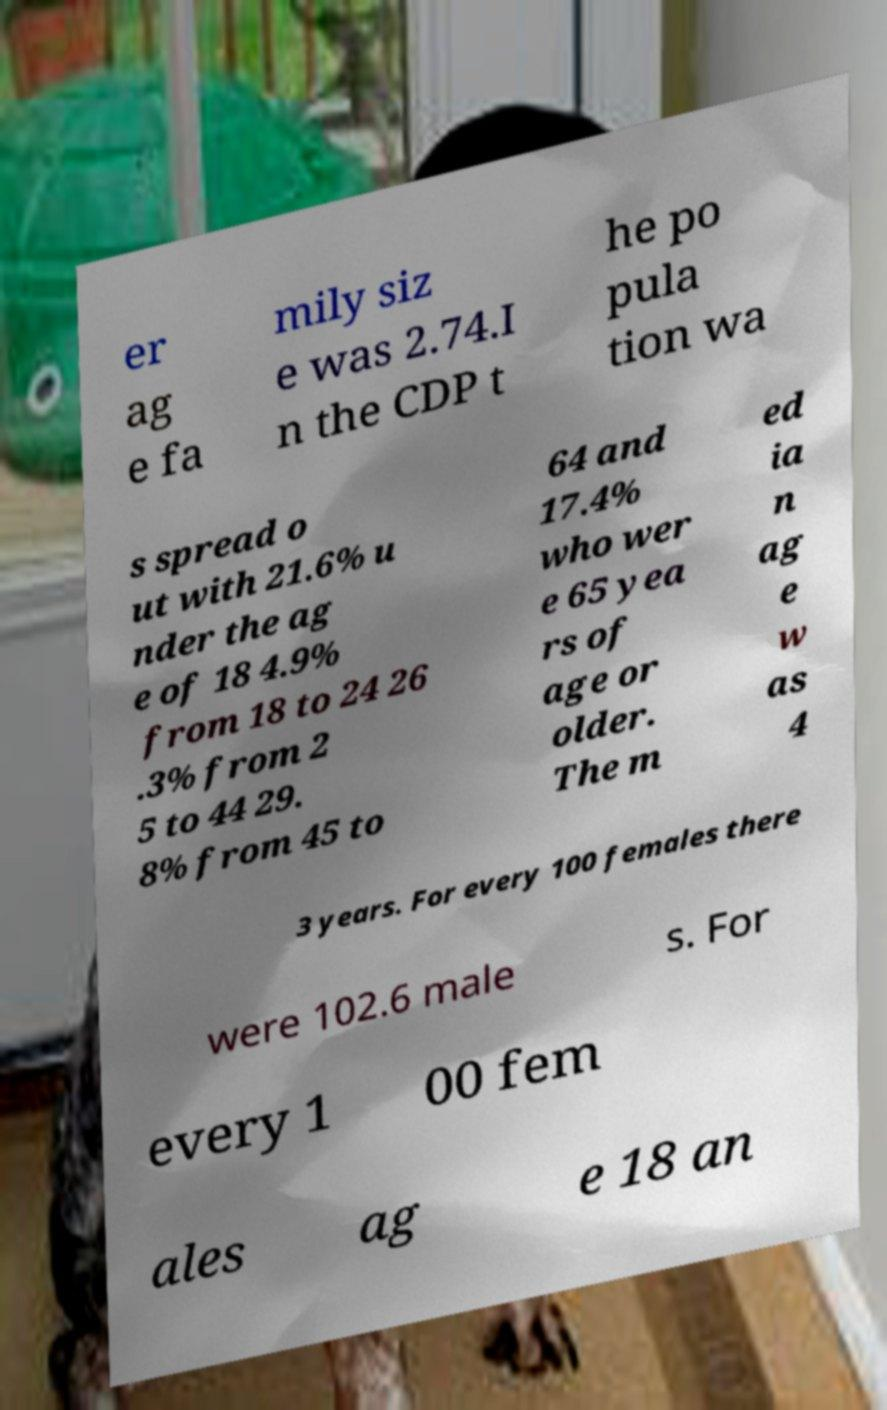For documentation purposes, I need the text within this image transcribed. Could you provide that? er ag e fa mily siz e was 2.74.I n the CDP t he po pula tion wa s spread o ut with 21.6% u nder the ag e of 18 4.9% from 18 to 24 26 .3% from 2 5 to 44 29. 8% from 45 to 64 and 17.4% who wer e 65 yea rs of age or older. The m ed ia n ag e w as 4 3 years. For every 100 females there were 102.6 male s. For every 1 00 fem ales ag e 18 an 